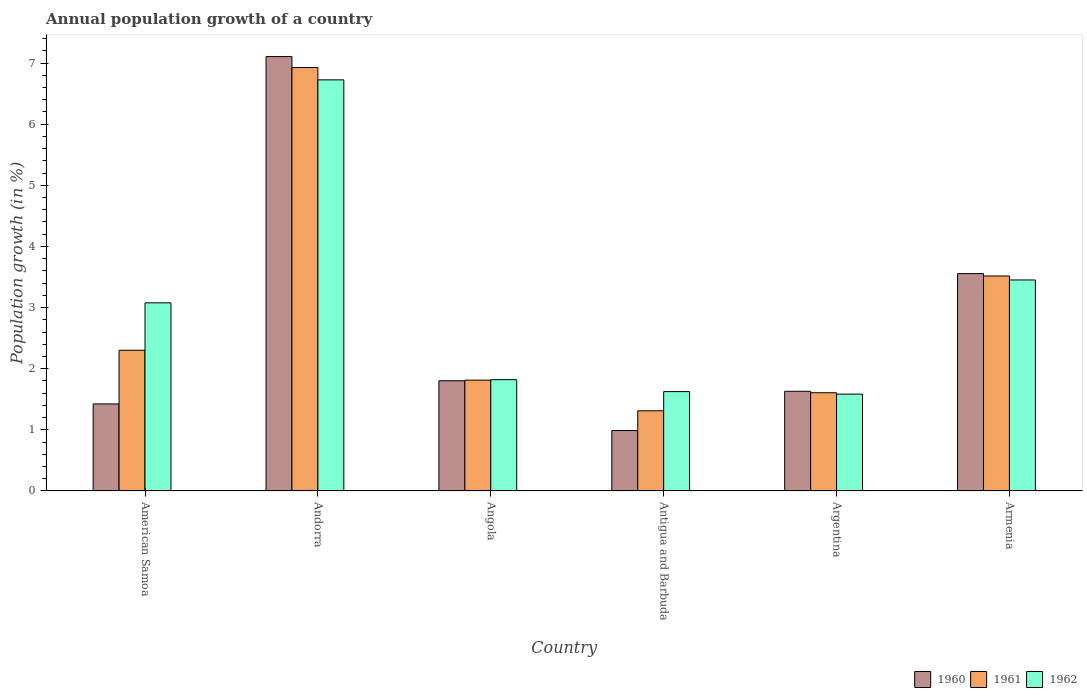How many different coloured bars are there?
Offer a terse response. 3. Are the number of bars per tick equal to the number of legend labels?
Give a very brief answer. Yes. Are the number of bars on each tick of the X-axis equal?
Make the answer very short. Yes. How many bars are there on the 3rd tick from the left?
Your answer should be very brief. 3. How many bars are there on the 5th tick from the right?
Keep it short and to the point. 3. What is the label of the 6th group of bars from the left?
Make the answer very short. Armenia. In how many cases, is the number of bars for a given country not equal to the number of legend labels?
Your answer should be compact. 0. What is the annual population growth in 1962 in Antigua and Barbuda?
Provide a succinct answer. 1.63. Across all countries, what is the maximum annual population growth in 1960?
Make the answer very short. 7.11. Across all countries, what is the minimum annual population growth in 1960?
Provide a succinct answer. 0.99. In which country was the annual population growth in 1960 maximum?
Your answer should be compact. Andorra. What is the total annual population growth in 1961 in the graph?
Your answer should be very brief. 17.48. What is the difference between the annual population growth in 1960 in Angola and that in Argentina?
Keep it short and to the point. 0.17. What is the difference between the annual population growth in 1961 in Andorra and the annual population growth in 1962 in Argentina?
Offer a very short reply. 5.34. What is the average annual population growth in 1961 per country?
Make the answer very short. 2.91. What is the difference between the annual population growth of/in 1962 and annual population growth of/in 1960 in Argentina?
Offer a terse response. -0.05. In how many countries, is the annual population growth in 1960 greater than 5.8 %?
Offer a terse response. 1. What is the ratio of the annual population growth in 1961 in Angola to that in Antigua and Barbuda?
Provide a succinct answer. 1.38. Is the annual population growth in 1960 in Angola less than that in Armenia?
Your answer should be compact. Yes. What is the difference between the highest and the second highest annual population growth in 1961?
Keep it short and to the point. -1.21. What is the difference between the highest and the lowest annual population growth in 1961?
Offer a very short reply. 5.61. In how many countries, is the annual population growth in 1961 greater than the average annual population growth in 1961 taken over all countries?
Provide a short and direct response. 2. Is the sum of the annual population growth in 1960 in Argentina and Armenia greater than the maximum annual population growth in 1961 across all countries?
Keep it short and to the point. No. What does the 2nd bar from the left in Armenia represents?
Your response must be concise. 1961. What does the 2nd bar from the right in American Samoa represents?
Your answer should be very brief. 1961. Is it the case that in every country, the sum of the annual population growth in 1960 and annual population growth in 1962 is greater than the annual population growth in 1961?
Offer a very short reply. Yes. What is the difference between two consecutive major ticks on the Y-axis?
Offer a terse response. 1. Does the graph contain any zero values?
Your answer should be very brief. No. Does the graph contain grids?
Offer a terse response. No. How many legend labels are there?
Provide a succinct answer. 3. What is the title of the graph?
Offer a terse response. Annual population growth of a country. Does "1980" appear as one of the legend labels in the graph?
Your answer should be very brief. No. What is the label or title of the Y-axis?
Offer a terse response. Population growth (in %). What is the Population growth (in %) of 1960 in American Samoa?
Your answer should be very brief. 1.42. What is the Population growth (in %) of 1961 in American Samoa?
Provide a succinct answer. 2.3. What is the Population growth (in %) of 1962 in American Samoa?
Make the answer very short. 3.08. What is the Population growth (in %) in 1960 in Andorra?
Offer a terse response. 7.11. What is the Population growth (in %) in 1961 in Andorra?
Keep it short and to the point. 6.93. What is the Population growth (in %) in 1962 in Andorra?
Your answer should be very brief. 6.72. What is the Population growth (in %) in 1960 in Angola?
Keep it short and to the point. 1.8. What is the Population growth (in %) of 1961 in Angola?
Offer a terse response. 1.81. What is the Population growth (in %) of 1962 in Angola?
Provide a short and direct response. 1.82. What is the Population growth (in %) of 1960 in Antigua and Barbuda?
Offer a very short reply. 0.99. What is the Population growth (in %) in 1961 in Antigua and Barbuda?
Give a very brief answer. 1.31. What is the Population growth (in %) in 1962 in Antigua and Barbuda?
Keep it short and to the point. 1.63. What is the Population growth (in %) in 1960 in Argentina?
Give a very brief answer. 1.63. What is the Population growth (in %) of 1961 in Argentina?
Ensure brevity in your answer.  1.61. What is the Population growth (in %) in 1962 in Argentina?
Your response must be concise. 1.58. What is the Population growth (in %) of 1960 in Armenia?
Make the answer very short. 3.56. What is the Population growth (in %) in 1961 in Armenia?
Provide a succinct answer. 3.52. What is the Population growth (in %) of 1962 in Armenia?
Offer a terse response. 3.45. Across all countries, what is the maximum Population growth (in %) of 1960?
Ensure brevity in your answer.  7.11. Across all countries, what is the maximum Population growth (in %) in 1961?
Ensure brevity in your answer.  6.93. Across all countries, what is the maximum Population growth (in %) of 1962?
Ensure brevity in your answer.  6.72. Across all countries, what is the minimum Population growth (in %) in 1960?
Give a very brief answer. 0.99. Across all countries, what is the minimum Population growth (in %) in 1961?
Your answer should be very brief. 1.31. Across all countries, what is the minimum Population growth (in %) in 1962?
Offer a terse response. 1.58. What is the total Population growth (in %) in 1960 in the graph?
Your response must be concise. 16.51. What is the total Population growth (in %) of 1961 in the graph?
Provide a succinct answer. 17.48. What is the total Population growth (in %) in 1962 in the graph?
Provide a short and direct response. 18.28. What is the difference between the Population growth (in %) of 1960 in American Samoa and that in Andorra?
Make the answer very short. -5.68. What is the difference between the Population growth (in %) in 1961 in American Samoa and that in Andorra?
Keep it short and to the point. -4.62. What is the difference between the Population growth (in %) in 1962 in American Samoa and that in Andorra?
Give a very brief answer. -3.65. What is the difference between the Population growth (in %) in 1960 in American Samoa and that in Angola?
Make the answer very short. -0.38. What is the difference between the Population growth (in %) in 1961 in American Samoa and that in Angola?
Provide a succinct answer. 0.49. What is the difference between the Population growth (in %) in 1962 in American Samoa and that in Angola?
Your answer should be compact. 1.26. What is the difference between the Population growth (in %) in 1960 in American Samoa and that in Antigua and Barbuda?
Keep it short and to the point. 0.44. What is the difference between the Population growth (in %) in 1961 in American Samoa and that in Antigua and Barbuda?
Your response must be concise. 0.99. What is the difference between the Population growth (in %) in 1962 in American Samoa and that in Antigua and Barbuda?
Offer a very short reply. 1.45. What is the difference between the Population growth (in %) in 1960 in American Samoa and that in Argentina?
Offer a terse response. -0.21. What is the difference between the Population growth (in %) of 1961 in American Samoa and that in Argentina?
Ensure brevity in your answer.  0.69. What is the difference between the Population growth (in %) in 1962 in American Samoa and that in Argentina?
Provide a succinct answer. 1.49. What is the difference between the Population growth (in %) in 1960 in American Samoa and that in Armenia?
Provide a succinct answer. -2.13. What is the difference between the Population growth (in %) of 1961 in American Samoa and that in Armenia?
Offer a very short reply. -1.22. What is the difference between the Population growth (in %) in 1962 in American Samoa and that in Armenia?
Offer a terse response. -0.37. What is the difference between the Population growth (in %) of 1960 in Andorra and that in Angola?
Your answer should be compact. 5.3. What is the difference between the Population growth (in %) of 1961 in Andorra and that in Angola?
Your answer should be compact. 5.11. What is the difference between the Population growth (in %) of 1962 in Andorra and that in Angola?
Make the answer very short. 4.9. What is the difference between the Population growth (in %) in 1960 in Andorra and that in Antigua and Barbuda?
Ensure brevity in your answer.  6.12. What is the difference between the Population growth (in %) in 1961 in Andorra and that in Antigua and Barbuda?
Your answer should be very brief. 5.61. What is the difference between the Population growth (in %) in 1962 in Andorra and that in Antigua and Barbuda?
Your response must be concise. 5.1. What is the difference between the Population growth (in %) of 1960 in Andorra and that in Argentina?
Provide a succinct answer. 5.47. What is the difference between the Population growth (in %) in 1961 in Andorra and that in Argentina?
Offer a terse response. 5.32. What is the difference between the Population growth (in %) of 1962 in Andorra and that in Argentina?
Ensure brevity in your answer.  5.14. What is the difference between the Population growth (in %) of 1960 in Andorra and that in Armenia?
Your answer should be compact. 3.55. What is the difference between the Population growth (in %) in 1961 in Andorra and that in Armenia?
Make the answer very short. 3.41. What is the difference between the Population growth (in %) of 1962 in Andorra and that in Armenia?
Your answer should be very brief. 3.27. What is the difference between the Population growth (in %) in 1960 in Angola and that in Antigua and Barbuda?
Ensure brevity in your answer.  0.81. What is the difference between the Population growth (in %) of 1961 in Angola and that in Antigua and Barbuda?
Provide a succinct answer. 0.5. What is the difference between the Population growth (in %) of 1962 in Angola and that in Antigua and Barbuda?
Your answer should be compact. 0.2. What is the difference between the Population growth (in %) in 1960 in Angola and that in Argentina?
Ensure brevity in your answer.  0.17. What is the difference between the Population growth (in %) of 1961 in Angola and that in Argentina?
Your answer should be compact. 0.21. What is the difference between the Population growth (in %) in 1962 in Angola and that in Argentina?
Make the answer very short. 0.24. What is the difference between the Population growth (in %) in 1960 in Angola and that in Armenia?
Ensure brevity in your answer.  -1.75. What is the difference between the Population growth (in %) of 1961 in Angola and that in Armenia?
Give a very brief answer. -1.7. What is the difference between the Population growth (in %) of 1962 in Angola and that in Armenia?
Provide a short and direct response. -1.63. What is the difference between the Population growth (in %) of 1960 in Antigua and Barbuda and that in Argentina?
Give a very brief answer. -0.64. What is the difference between the Population growth (in %) of 1961 in Antigua and Barbuda and that in Argentina?
Offer a terse response. -0.3. What is the difference between the Population growth (in %) in 1962 in Antigua and Barbuda and that in Argentina?
Your response must be concise. 0.04. What is the difference between the Population growth (in %) in 1960 in Antigua and Barbuda and that in Armenia?
Make the answer very short. -2.57. What is the difference between the Population growth (in %) in 1961 in Antigua and Barbuda and that in Armenia?
Your answer should be very brief. -2.21. What is the difference between the Population growth (in %) in 1962 in Antigua and Barbuda and that in Armenia?
Offer a very short reply. -1.83. What is the difference between the Population growth (in %) of 1960 in Argentina and that in Armenia?
Your answer should be compact. -1.92. What is the difference between the Population growth (in %) in 1961 in Argentina and that in Armenia?
Make the answer very short. -1.91. What is the difference between the Population growth (in %) of 1962 in Argentina and that in Armenia?
Give a very brief answer. -1.87. What is the difference between the Population growth (in %) of 1960 in American Samoa and the Population growth (in %) of 1961 in Andorra?
Your answer should be very brief. -5.5. What is the difference between the Population growth (in %) in 1960 in American Samoa and the Population growth (in %) in 1962 in Andorra?
Your response must be concise. -5.3. What is the difference between the Population growth (in %) in 1961 in American Samoa and the Population growth (in %) in 1962 in Andorra?
Offer a very short reply. -4.42. What is the difference between the Population growth (in %) in 1960 in American Samoa and the Population growth (in %) in 1961 in Angola?
Your response must be concise. -0.39. What is the difference between the Population growth (in %) of 1960 in American Samoa and the Population growth (in %) of 1962 in Angola?
Offer a very short reply. -0.4. What is the difference between the Population growth (in %) of 1961 in American Samoa and the Population growth (in %) of 1962 in Angola?
Ensure brevity in your answer.  0.48. What is the difference between the Population growth (in %) in 1960 in American Samoa and the Population growth (in %) in 1961 in Antigua and Barbuda?
Offer a very short reply. 0.11. What is the difference between the Population growth (in %) in 1960 in American Samoa and the Population growth (in %) in 1962 in Antigua and Barbuda?
Keep it short and to the point. -0.2. What is the difference between the Population growth (in %) in 1961 in American Samoa and the Population growth (in %) in 1962 in Antigua and Barbuda?
Offer a terse response. 0.68. What is the difference between the Population growth (in %) in 1960 in American Samoa and the Population growth (in %) in 1961 in Argentina?
Ensure brevity in your answer.  -0.18. What is the difference between the Population growth (in %) of 1960 in American Samoa and the Population growth (in %) of 1962 in Argentina?
Offer a very short reply. -0.16. What is the difference between the Population growth (in %) of 1961 in American Samoa and the Population growth (in %) of 1962 in Argentina?
Make the answer very short. 0.72. What is the difference between the Population growth (in %) of 1960 in American Samoa and the Population growth (in %) of 1961 in Armenia?
Your response must be concise. -2.09. What is the difference between the Population growth (in %) in 1960 in American Samoa and the Population growth (in %) in 1962 in Armenia?
Keep it short and to the point. -2.03. What is the difference between the Population growth (in %) of 1961 in American Samoa and the Population growth (in %) of 1962 in Armenia?
Keep it short and to the point. -1.15. What is the difference between the Population growth (in %) in 1960 in Andorra and the Population growth (in %) in 1961 in Angola?
Your response must be concise. 5.29. What is the difference between the Population growth (in %) of 1960 in Andorra and the Population growth (in %) of 1962 in Angola?
Ensure brevity in your answer.  5.28. What is the difference between the Population growth (in %) in 1961 in Andorra and the Population growth (in %) in 1962 in Angola?
Keep it short and to the point. 5.11. What is the difference between the Population growth (in %) of 1960 in Andorra and the Population growth (in %) of 1961 in Antigua and Barbuda?
Your answer should be very brief. 5.79. What is the difference between the Population growth (in %) in 1960 in Andorra and the Population growth (in %) in 1962 in Antigua and Barbuda?
Offer a terse response. 5.48. What is the difference between the Population growth (in %) in 1961 in Andorra and the Population growth (in %) in 1962 in Antigua and Barbuda?
Provide a short and direct response. 5.3. What is the difference between the Population growth (in %) in 1960 in Andorra and the Population growth (in %) in 1961 in Argentina?
Offer a very short reply. 5.5. What is the difference between the Population growth (in %) of 1960 in Andorra and the Population growth (in %) of 1962 in Argentina?
Your response must be concise. 5.52. What is the difference between the Population growth (in %) of 1961 in Andorra and the Population growth (in %) of 1962 in Argentina?
Keep it short and to the point. 5.34. What is the difference between the Population growth (in %) in 1960 in Andorra and the Population growth (in %) in 1961 in Armenia?
Offer a very short reply. 3.59. What is the difference between the Population growth (in %) of 1960 in Andorra and the Population growth (in %) of 1962 in Armenia?
Provide a short and direct response. 3.65. What is the difference between the Population growth (in %) of 1961 in Andorra and the Population growth (in %) of 1962 in Armenia?
Offer a very short reply. 3.47. What is the difference between the Population growth (in %) of 1960 in Angola and the Population growth (in %) of 1961 in Antigua and Barbuda?
Give a very brief answer. 0.49. What is the difference between the Population growth (in %) of 1960 in Angola and the Population growth (in %) of 1962 in Antigua and Barbuda?
Ensure brevity in your answer.  0.18. What is the difference between the Population growth (in %) in 1961 in Angola and the Population growth (in %) in 1962 in Antigua and Barbuda?
Ensure brevity in your answer.  0.19. What is the difference between the Population growth (in %) in 1960 in Angola and the Population growth (in %) in 1961 in Argentina?
Keep it short and to the point. 0.2. What is the difference between the Population growth (in %) in 1960 in Angola and the Population growth (in %) in 1962 in Argentina?
Provide a succinct answer. 0.22. What is the difference between the Population growth (in %) of 1961 in Angola and the Population growth (in %) of 1962 in Argentina?
Make the answer very short. 0.23. What is the difference between the Population growth (in %) of 1960 in Angola and the Population growth (in %) of 1961 in Armenia?
Your answer should be very brief. -1.71. What is the difference between the Population growth (in %) in 1960 in Angola and the Population growth (in %) in 1962 in Armenia?
Provide a short and direct response. -1.65. What is the difference between the Population growth (in %) of 1961 in Angola and the Population growth (in %) of 1962 in Armenia?
Offer a very short reply. -1.64. What is the difference between the Population growth (in %) in 1960 in Antigua and Barbuda and the Population growth (in %) in 1961 in Argentina?
Make the answer very short. -0.62. What is the difference between the Population growth (in %) of 1960 in Antigua and Barbuda and the Population growth (in %) of 1962 in Argentina?
Ensure brevity in your answer.  -0.6. What is the difference between the Population growth (in %) in 1961 in Antigua and Barbuda and the Population growth (in %) in 1962 in Argentina?
Offer a very short reply. -0.27. What is the difference between the Population growth (in %) in 1960 in Antigua and Barbuda and the Population growth (in %) in 1961 in Armenia?
Give a very brief answer. -2.53. What is the difference between the Population growth (in %) in 1960 in Antigua and Barbuda and the Population growth (in %) in 1962 in Armenia?
Give a very brief answer. -2.46. What is the difference between the Population growth (in %) of 1961 in Antigua and Barbuda and the Population growth (in %) of 1962 in Armenia?
Give a very brief answer. -2.14. What is the difference between the Population growth (in %) in 1960 in Argentina and the Population growth (in %) in 1961 in Armenia?
Your answer should be compact. -1.89. What is the difference between the Population growth (in %) of 1960 in Argentina and the Population growth (in %) of 1962 in Armenia?
Offer a very short reply. -1.82. What is the difference between the Population growth (in %) of 1961 in Argentina and the Population growth (in %) of 1962 in Armenia?
Keep it short and to the point. -1.84. What is the average Population growth (in %) of 1960 per country?
Give a very brief answer. 2.75. What is the average Population growth (in %) in 1961 per country?
Give a very brief answer. 2.91. What is the average Population growth (in %) of 1962 per country?
Your answer should be compact. 3.05. What is the difference between the Population growth (in %) of 1960 and Population growth (in %) of 1961 in American Samoa?
Offer a very short reply. -0.88. What is the difference between the Population growth (in %) of 1960 and Population growth (in %) of 1962 in American Samoa?
Provide a short and direct response. -1.65. What is the difference between the Population growth (in %) of 1961 and Population growth (in %) of 1962 in American Samoa?
Provide a succinct answer. -0.78. What is the difference between the Population growth (in %) of 1960 and Population growth (in %) of 1961 in Andorra?
Your answer should be compact. 0.18. What is the difference between the Population growth (in %) in 1960 and Population growth (in %) in 1962 in Andorra?
Offer a terse response. 0.38. What is the difference between the Population growth (in %) of 1961 and Population growth (in %) of 1962 in Andorra?
Provide a short and direct response. 0.2. What is the difference between the Population growth (in %) in 1960 and Population growth (in %) in 1961 in Angola?
Keep it short and to the point. -0.01. What is the difference between the Population growth (in %) of 1960 and Population growth (in %) of 1962 in Angola?
Your response must be concise. -0.02. What is the difference between the Population growth (in %) in 1961 and Population growth (in %) in 1962 in Angola?
Your answer should be very brief. -0.01. What is the difference between the Population growth (in %) of 1960 and Population growth (in %) of 1961 in Antigua and Barbuda?
Ensure brevity in your answer.  -0.32. What is the difference between the Population growth (in %) in 1960 and Population growth (in %) in 1962 in Antigua and Barbuda?
Your response must be concise. -0.64. What is the difference between the Population growth (in %) in 1961 and Population growth (in %) in 1962 in Antigua and Barbuda?
Your answer should be very brief. -0.31. What is the difference between the Population growth (in %) in 1960 and Population growth (in %) in 1961 in Argentina?
Provide a succinct answer. 0.02. What is the difference between the Population growth (in %) of 1960 and Population growth (in %) of 1962 in Argentina?
Offer a terse response. 0.05. What is the difference between the Population growth (in %) in 1961 and Population growth (in %) in 1962 in Argentina?
Give a very brief answer. 0.02. What is the difference between the Population growth (in %) in 1960 and Population growth (in %) in 1961 in Armenia?
Your answer should be compact. 0.04. What is the difference between the Population growth (in %) in 1960 and Population growth (in %) in 1962 in Armenia?
Offer a terse response. 0.1. What is the difference between the Population growth (in %) of 1961 and Population growth (in %) of 1962 in Armenia?
Give a very brief answer. 0.07. What is the ratio of the Population growth (in %) in 1960 in American Samoa to that in Andorra?
Your answer should be compact. 0.2. What is the ratio of the Population growth (in %) of 1961 in American Samoa to that in Andorra?
Give a very brief answer. 0.33. What is the ratio of the Population growth (in %) in 1962 in American Samoa to that in Andorra?
Offer a terse response. 0.46. What is the ratio of the Population growth (in %) of 1960 in American Samoa to that in Angola?
Provide a succinct answer. 0.79. What is the ratio of the Population growth (in %) of 1961 in American Samoa to that in Angola?
Offer a terse response. 1.27. What is the ratio of the Population growth (in %) in 1962 in American Samoa to that in Angola?
Ensure brevity in your answer.  1.69. What is the ratio of the Population growth (in %) of 1960 in American Samoa to that in Antigua and Barbuda?
Provide a short and direct response. 1.44. What is the ratio of the Population growth (in %) of 1961 in American Samoa to that in Antigua and Barbuda?
Your response must be concise. 1.75. What is the ratio of the Population growth (in %) of 1962 in American Samoa to that in Antigua and Barbuda?
Offer a very short reply. 1.89. What is the ratio of the Population growth (in %) of 1960 in American Samoa to that in Argentina?
Give a very brief answer. 0.87. What is the ratio of the Population growth (in %) of 1961 in American Samoa to that in Argentina?
Provide a short and direct response. 1.43. What is the ratio of the Population growth (in %) of 1962 in American Samoa to that in Argentina?
Ensure brevity in your answer.  1.94. What is the ratio of the Population growth (in %) of 1960 in American Samoa to that in Armenia?
Your answer should be very brief. 0.4. What is the ratio of the Population growth (in %) in 1961 in American Samoa to that in Armenia?
Your answer should be very brief. 0.65. What is the ratio of the Population growth (in %) in 1962 in American Samoa to that in Armenia?
Give a very brief answer. 0.89. What is the ratio of the Population growth (in %) in 1960 in Andorra to that in Angola?
Offer a terse response. 3.94. What is the ratio of the Population growth (in %) in 1961 in Andorra to that in Angola?
Ensure brevity in your answer.  3.82. What is the ratio of the Population growth (in %) of 1962 in Andorra to that in Angola?
Offer a terse response. 3.69. What is the ratio of the Population growth (in %) of 1960 in Andorra to that in Antigua and Barbuda?
Give a very brief answer. 7.19. What is the ratio of the Population growth (in %) of 1961 in Andorra to that in Antigua and Barbuda?
Your answer should be very brief. 5.28. What is the ratio of the Population growth (in %) of 1962 in Andorra to that in Antigua and Barbuda?
Ensure brevity in your answer.  4.14. What is the ratio of the Population growth (in %) of 1960 in Andorra to that in Argentina?
Ensure brevity in your answer.  4.36. What is the ratio of the Population growth (in %) of 1961 in Andorra to that in Argentina?
Offer a terse response. 4.31. What is the ratio of the Population growth (in %) in 1962 in Andorra to that in Argentina?
Make the answer very short. 4.24. What is the ratio of the Population growth (in %) of 1960 in Andorra to that in Armenia?
Give a very brief answer. 2. What is the ratio of the Population growth (in %) of 1961 in Andorra to that in Armenia?
Give a very brief answer. 1.97. What is the ratio of the Population growth (in %) of 1962 in Andorra to that in Armenia?
Provide a succinct answer. 1.95. What is the ratio of the Population growth (in %) in 1960 in Angola to that in Antigua and Barbuda?
Your answer should be very brief. 1.82. What is the ratio of the Population growth (in %) in 1961 in Angola to that in Antigua and Barbuda?
Give a very brief answer. 1.38. What is the ratio of the Population growth (in %) of 1962 in Angola to that in Antigua and Barbuda?
Offer a very short reply. 1.12. What is the ratio of the Population growth (in %) of 1960 in Angola to that in Argentina?
Offer a very short reply. 1.11. What is the ratio of the Population growth (in %) of 1961 in Angola to that in Argentina?
Make the answer very short. 1.13. What is the ratio of the Population growth (in %) in 1962 in Angola to that in Argentina?
Offer a very short reply. 1.15. What is the ratio of the Population growth (in %) of 1960 in Angola to that in Armenia?
Your answer should be compact. 0.51. What is the ratio of the Population growth (in %) in 1961 in Angola to that in Armenia?
Provide a succinct answer. 0.52. What is the ratio of the Population growth (in %) of 1962 in Angola to that in Armenia?
Your response must be concise. 0.53. What is the ratio of the Population growth (in %) of 1960 in Antigua and Barbuda to that in Argentina?
Provide a succinct answer. 0.61. What is the ratio of the Population growth (in %) of 1961 in Antigua and Barbuda to that in Argentina?
Give a very brief answer. 0.82. What is the ratio of the Population growth (in %) of 1962 in Antigua and Barbuda to that in Argentina?
Ensure brevity in your answer.  1.03. What is the ratio of the Population growth (in %) of 1960 in Antigua and Barbuda to that in Armenia?
Make the answer very short. 0.28. What is the ratio of the Population growth (in %) in 1961 in Antigua and Barbuda to that in Armenia?
Provide a succinct answer. 0.37. What is the ratio of the Population growth (in %) of 1962 in Antigua and Barbuda to that in Armenia?
Make the answer very short. 0.47. What is the ratio of the Population growth (in %) of 1960 in Argentina to that in Armenia?
Keep it short and to the point. 0.46. What is the ratio of the Population growth (in %) in 1961 in Argentina to that in Armenia?
Make the answer very short. 0.46. What is the ratio of the Population growth (in %) of 1962 in Argentina to that in Armenia?
Ensure brevity in your answer.  0.46. What is the difference between the highest and the second highest Population growth (in %) in 1960?
Offer a very short reply. 3.55. What is the difference between the highest and the second highest Population growth (in %) in 1961?
Provide a succinct answer. 3.41. What is the difference between the highest and the second highest Population growth (in %) in 1962?
Your answer should be very brief. 3.27. What is the difference between the highest and the lowest Population growth (in %) in 1960?
Ensure brevity in your answer.  6.12. What is the difference between the highest and the lowest Population growth (in %) in 1961?
Keep it short and to the point. 5.61. What is the difference between the highest and the lowest Population growth (in %) in 1962?
Give a very brief answer. 5.14. 